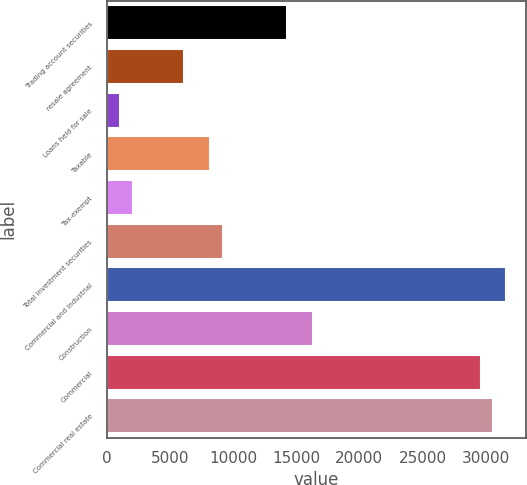Convert chart to OTSL. <chart><loc_0><loc_0><loc_500><loc_500><bar_chart><fcel>Trading account securities<fcel>resale agreement<fcel>Loans held for sale<fcel>Taxable<fcel>Tax-exempt<fcel>Total investment securities<fcel>Commercial and industrial<fcel>Construction<fcel>Commercial<fcel>Commercial real estate<nl><fcel>14291<fcel>6127<fcel>1024.5<fcel>8168<fcel>2045<fcel>9188.5<fcel>31639.5<fcel>16332<fcel>29598.5<fcel>30619<nl></chart> 